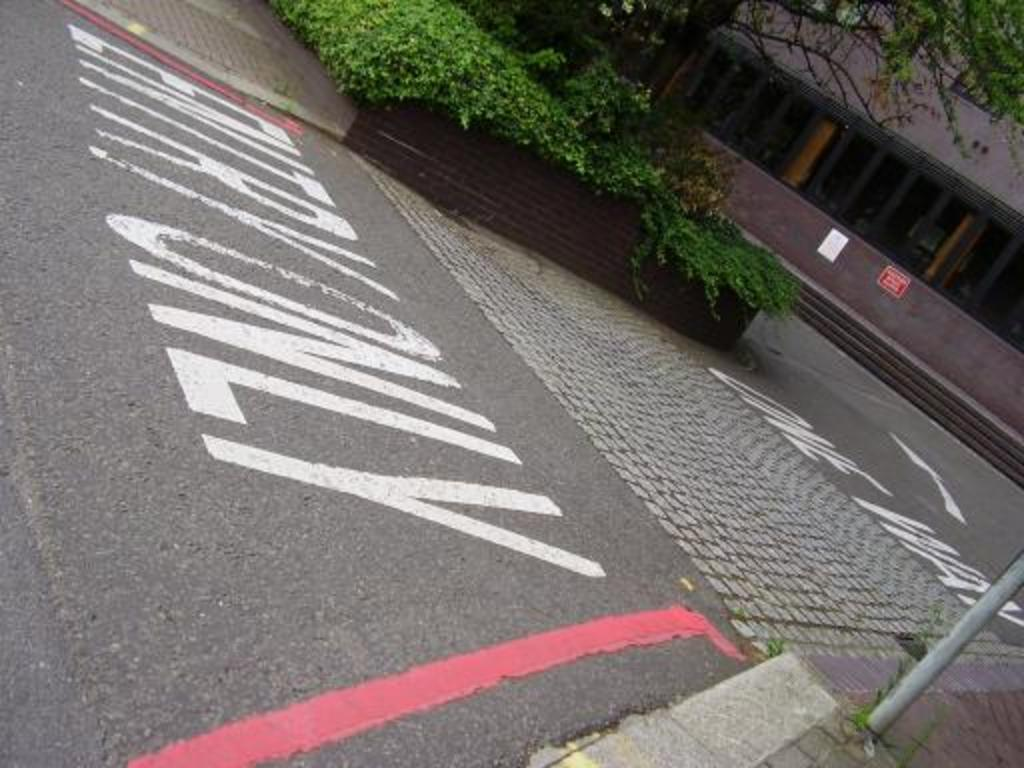What is the main feature of the image? There is a road in the image. What can be seen alongside the road? Plants are visible in the image. What is visible in the background of the image? There is a building and a tree in the background of the image. What object is located at the bottom of the image? There is a pole at the bottom of the image. What type of juice is being served at the table in the image? There is no table or juice present in the image; it features a road, plants, a building, a tree, and a pole. 